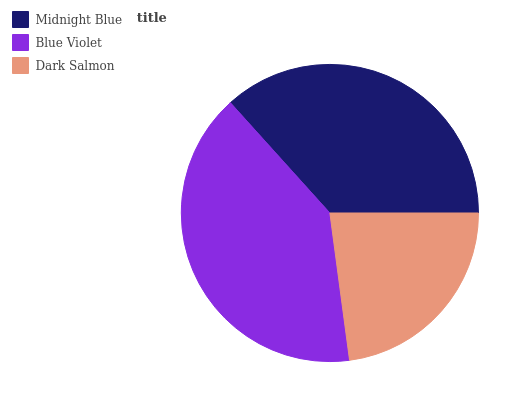Is Dark Salmon the minimum?
Answer yes or no. Yes. Is Blue Violet the maximum?
Answer yes or no. Yes. Is Blue Violet the minimum?
Answer yes or no. No. Is Dark Salmon the maximum?
Answer yes or no. No. Is Blue Violet greater than Dark Salmon?
Answer yes or no. Yes. Is Dark Salmon less than Blue Violet?
Answer yes or no. Yes. Is Dark Salmon greater than Blue Violet?
Answer yes or no. No. Is Blue Violet less than Dark Salmon?
Answer yes or no. No. Is Midnight Blue the high median?
Answer yes or no. Yes. Is Midnight Blue the low median?
Answer yes or no. Yes. Is Blue Violet the high median?
Answer yes or no. No. Is Dark Salmon the low median?
Answer yes or no. No. 